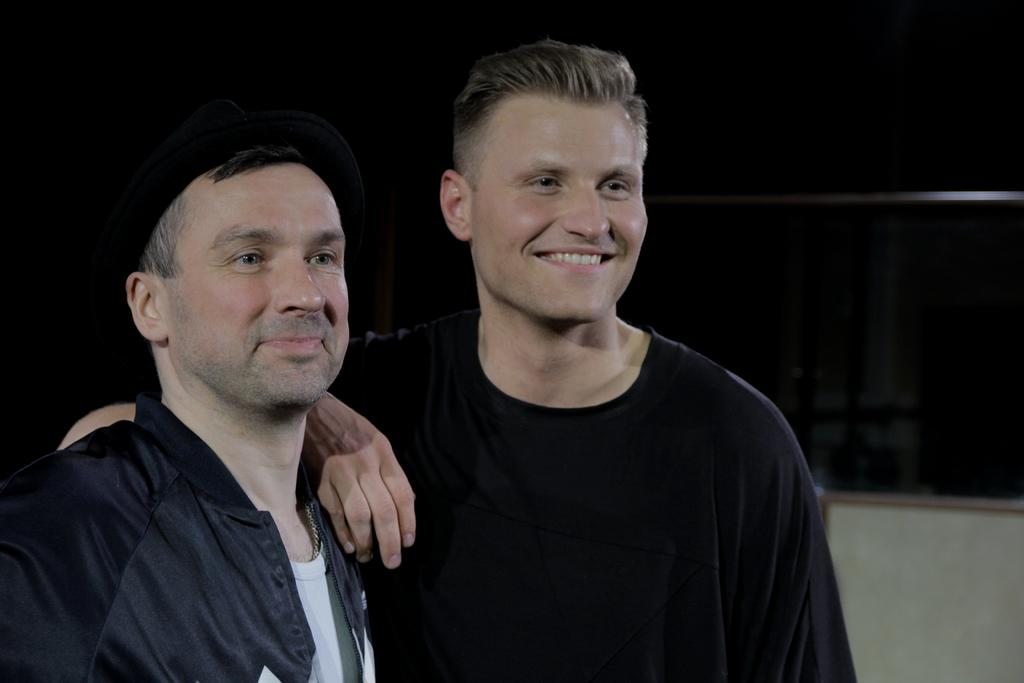How many people are in the image? There are persons in the image. Can you describe the clothing of one of the persons? One person is wearing a cap on the left side of the image. What type of structure can be seen in the image? There is a fence in the image. What is the color of the background in the image? The background of the image is dark. What type of limit is being enforced by the verse in the image? There is no mention of a limit or verse in the image; it features persons, a cap, a fence, and a dark background. 